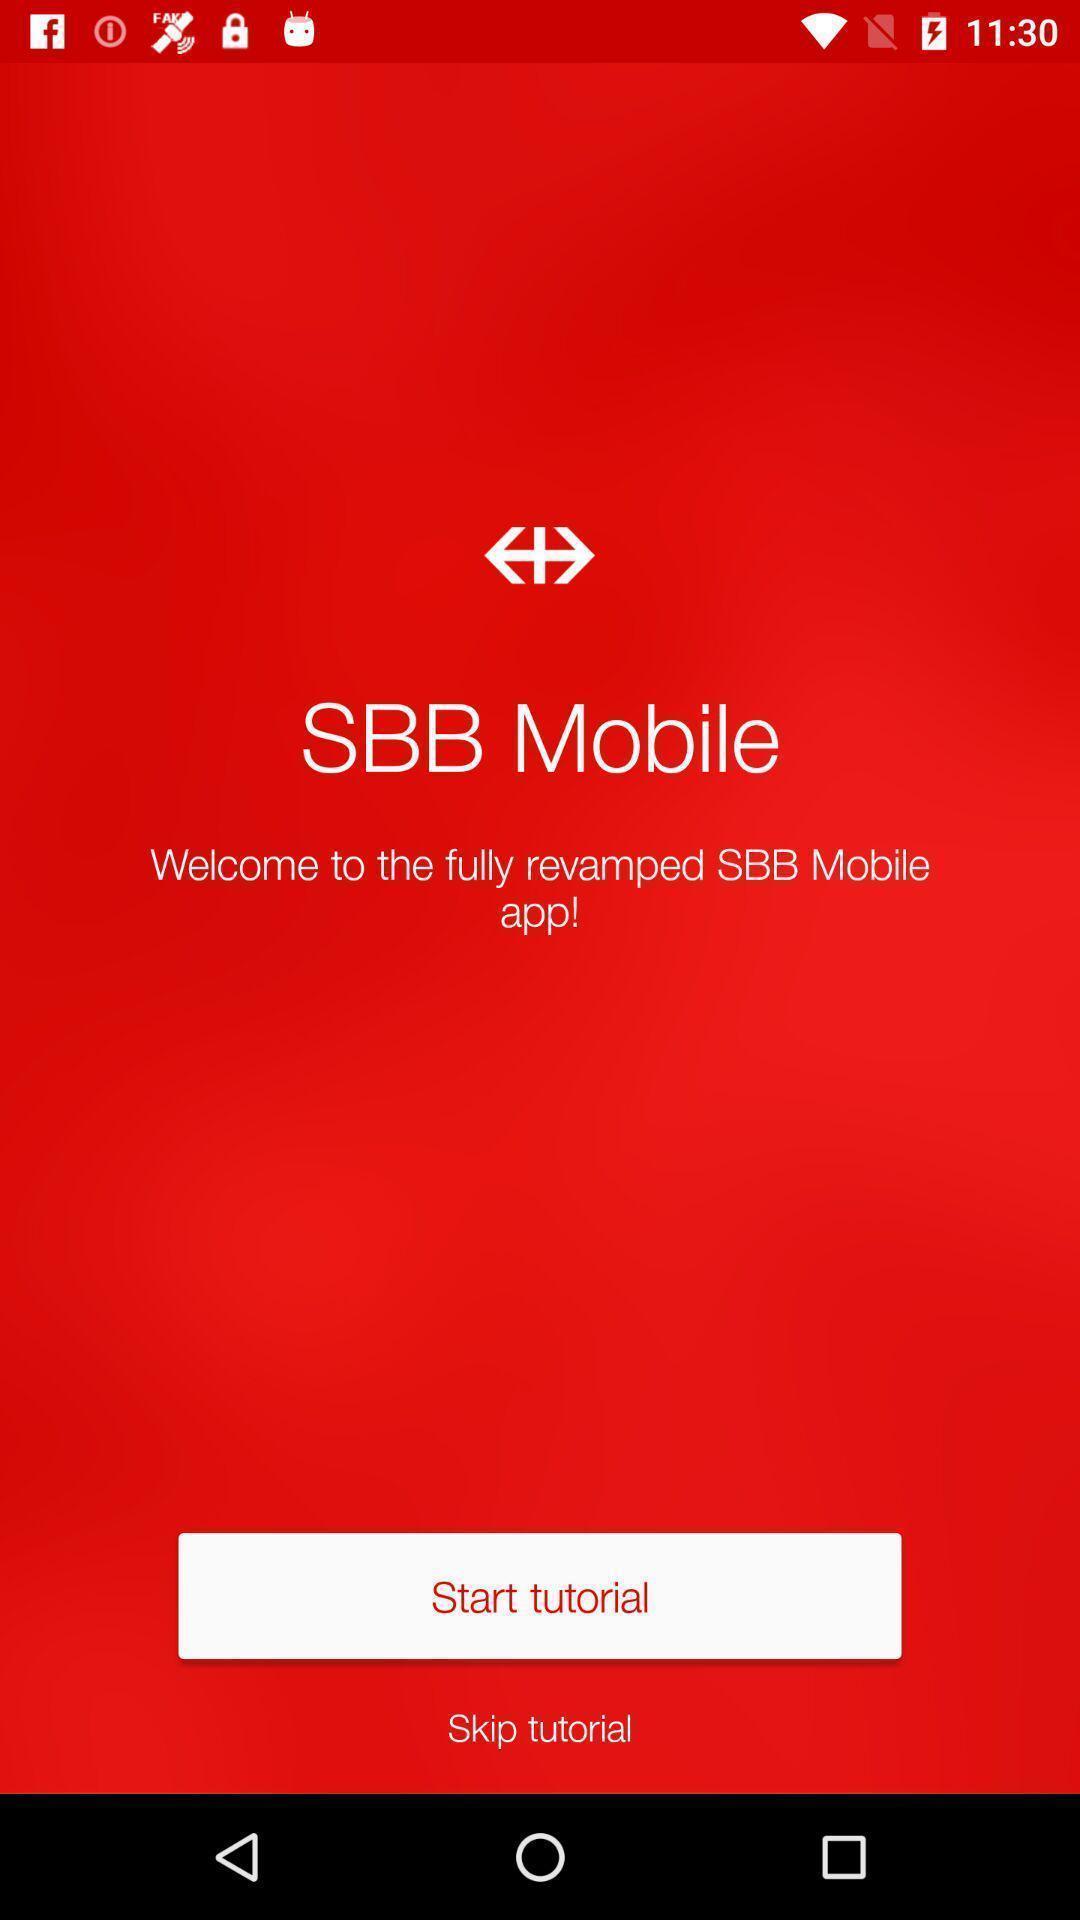What can you discern from this picture? Welcome page to start tutorial displayed. 